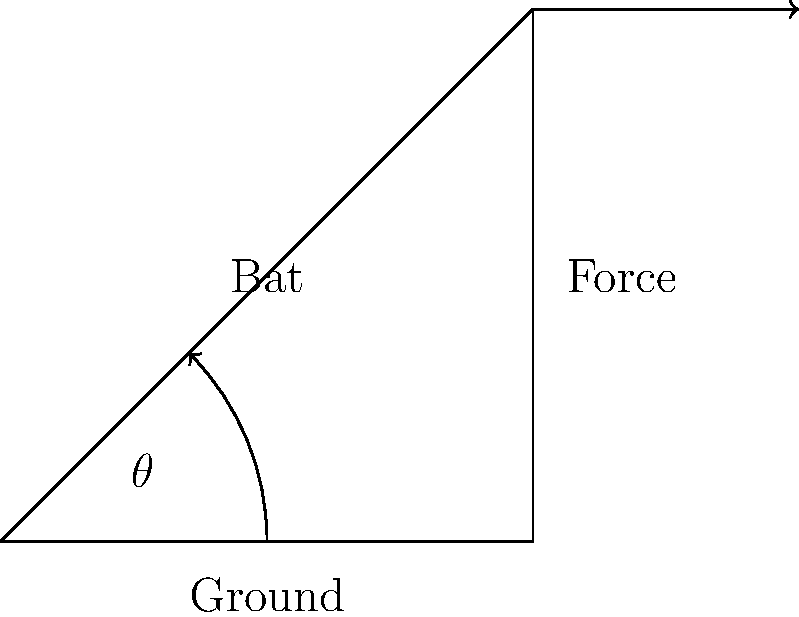As a powerful batsman, you want to maximize the force applied to the cricket ball. Given that the optimal angle for a cricket bat swing to maximize power is related to the angle between the bat and the ground, what is this optimal angle $\theta$ (in degrees) for achieving the greatest impact? To determine the optimal angle for maximizing power in a cricket bat swing, we need to consider the principles of physics and biomechanics:

1. The force applied to the ball is a combination of the bat's speed and the mass of the bat.

2. The optimal angle maximizes the transfer of energy from the bat to the ball.

3. In physics, this scenario is similar to the optimal angle for projectile motion, which is 45°.

4. However, in cricket, factors such as the height of the ball and the downward angle of the bat's swing slightly modify this angle.

5. Research and biomechanical studies have shown that the optimal angle for a cricket bat swing is slightly less than 45°.

6. The generally accepted optimal angle for a cricket bat swing to maximize power is approximately 40°.

This angle allows for:
- Maximum bat speed at the point of impact
- Optimal energy transfer to the ball
- A balance between horizontal and vertical components of force

It's important to note that this angle may vary slightly depending on the specific technique of the batsman and the type of shot being played, but 40° is considered the general optimal angle for powerful hitting.
Answer: 40° 